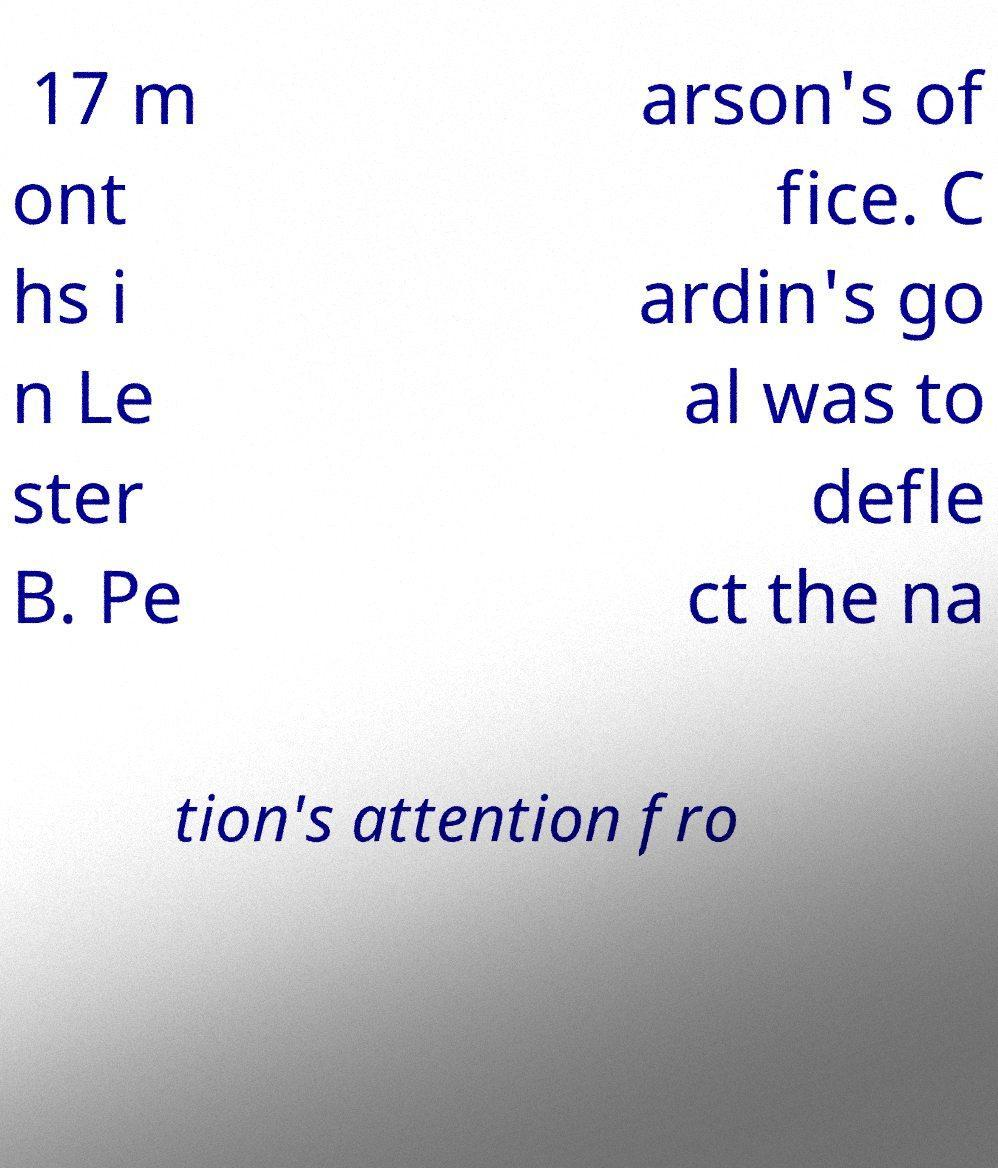For documentation purposes, I need the text within this image transcribed. Could you provide that? 17 m ont hs i n Le ster B. Pe arson's of fice. C ardin's go al was to defle ct the na tion's attention fro 